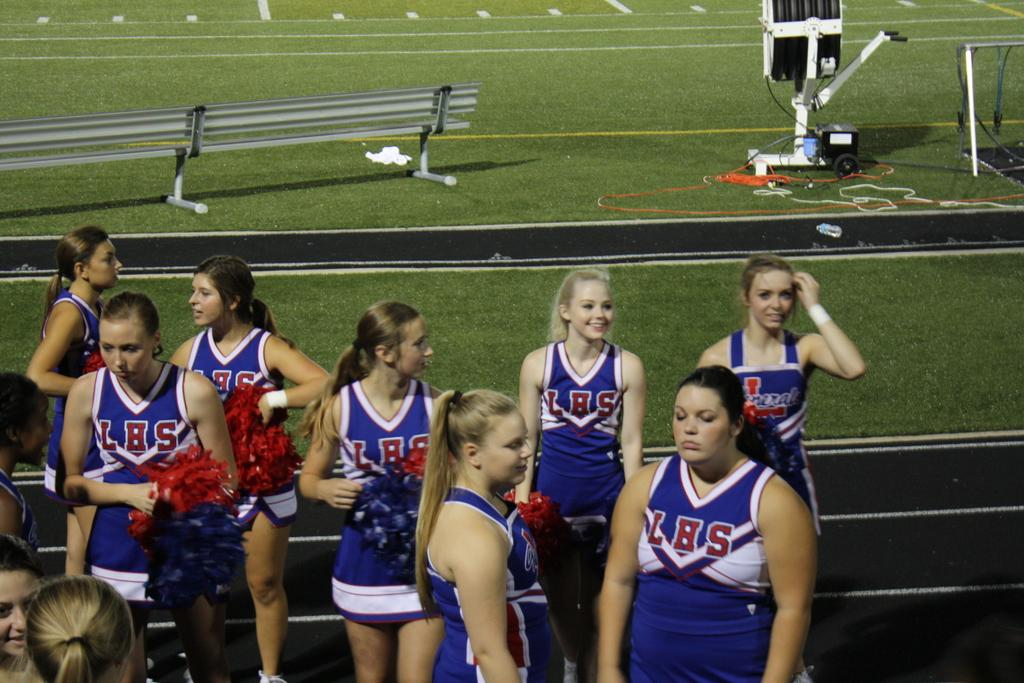Provide a one-sentence caption for the provided image. a group of cheerleaders with LBS on their outfits. 